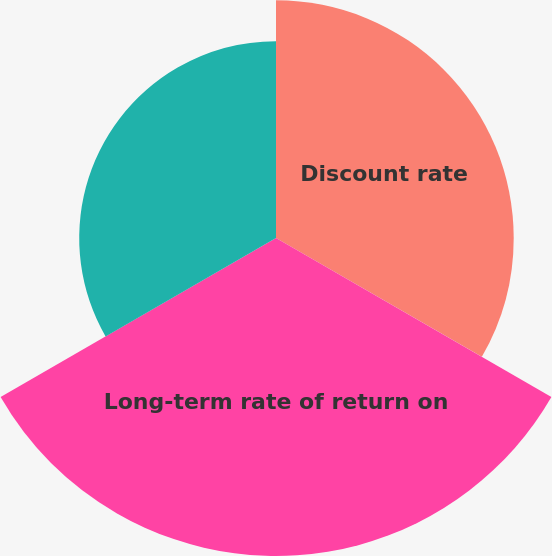<chart> <loc_0><loc_0><loc_500><loc_500><pie_chart><fcel>Discount rate<fcel>Long-term rate of return on<fcel>Rate of compensation increase<nl><fcel>31.59%<fcel>42.26%<fcel>26.15%<nl></chart> 